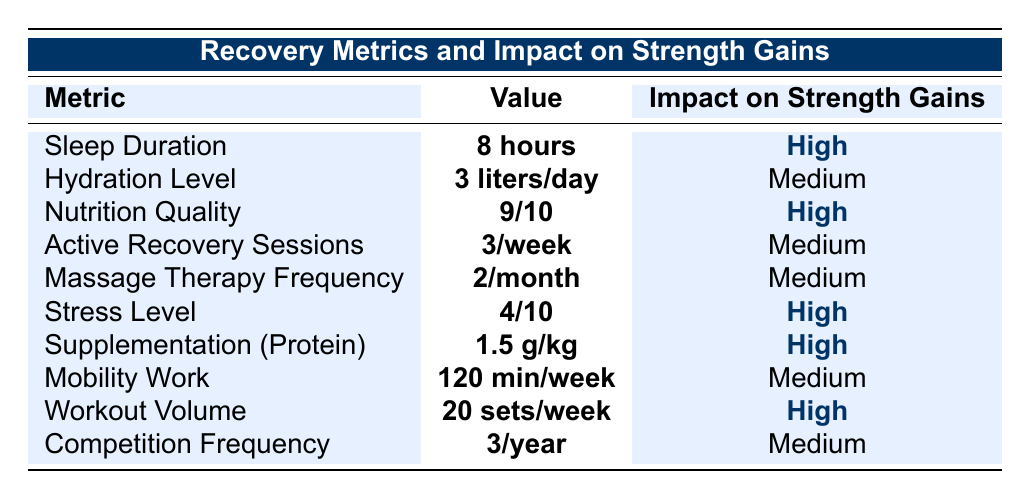What is the value for Sleep Duration? The table lists the value for Sleep Duration as **8 hours**.
Answer: 8 hours How many Active Recovery Sessions are recommended per week? The value for Active Recovery Sessions is stated as **3/week** in the table.
Answer: 3/week What is the impact of Nutrition Quality on strength gains? The impact of Nutrition Quality is indicated as **High** in the table.
Answer: High Is the value for Stress Level higher than 5? The table shows the value for Stress Level as **4** which is not higher than 5.
Answer: No What is the total number of sessions per month for Massage Therapy Frequency? The table states the value for Massage Therapy Frequency as **2/month**, so the total is 2.
Answer: 2 Which recovery metric has the highest impact on strength gains? The metrics with the highest impact on strength gains, highlighted in dark blue, are Sleep Duration, Nutrition Quality, Stress Level, Supplementation, and Workout Volume.
Answer: Sleep Duration, Nutrition Quality, Stress Level, Supplementation, Workout Volume What average hydration level leads to a medium impact on strength gains? According to the table, the hydration level stated is **3 liters/day**, which corresponds to a medium impact. Since there's only one metric with medium impact on hydration, it is the average.
Answer: 3 liters/day If a lifter experiences a stress level of 2, how would that impact their strength gains compared to a stress level of 4? A stress level of **4** correlates with a high impact on strength gains, whereas a lower stress level of **2** would likely result in even better recovery and thus a higher impact.
Answer: Higher impact What is the total number of hours for Sleep Duration and Mobility Work combined? Sleep Duration is **8 hours** and Mobility Work is represented as **120 minutes**, which converts to **2 hours**. Adding them together gives 8 + 2 = **10 hours**.
Answer: 10 hours What is the impact on strength gains if the Workout Volume is increased to 25 sets/week? The table states that the current impact of 20 sets/week is **High**, and generally, increasing the workout volume can enhance strength gains further, likely maintaining a High impact.
Answer: Likely High 